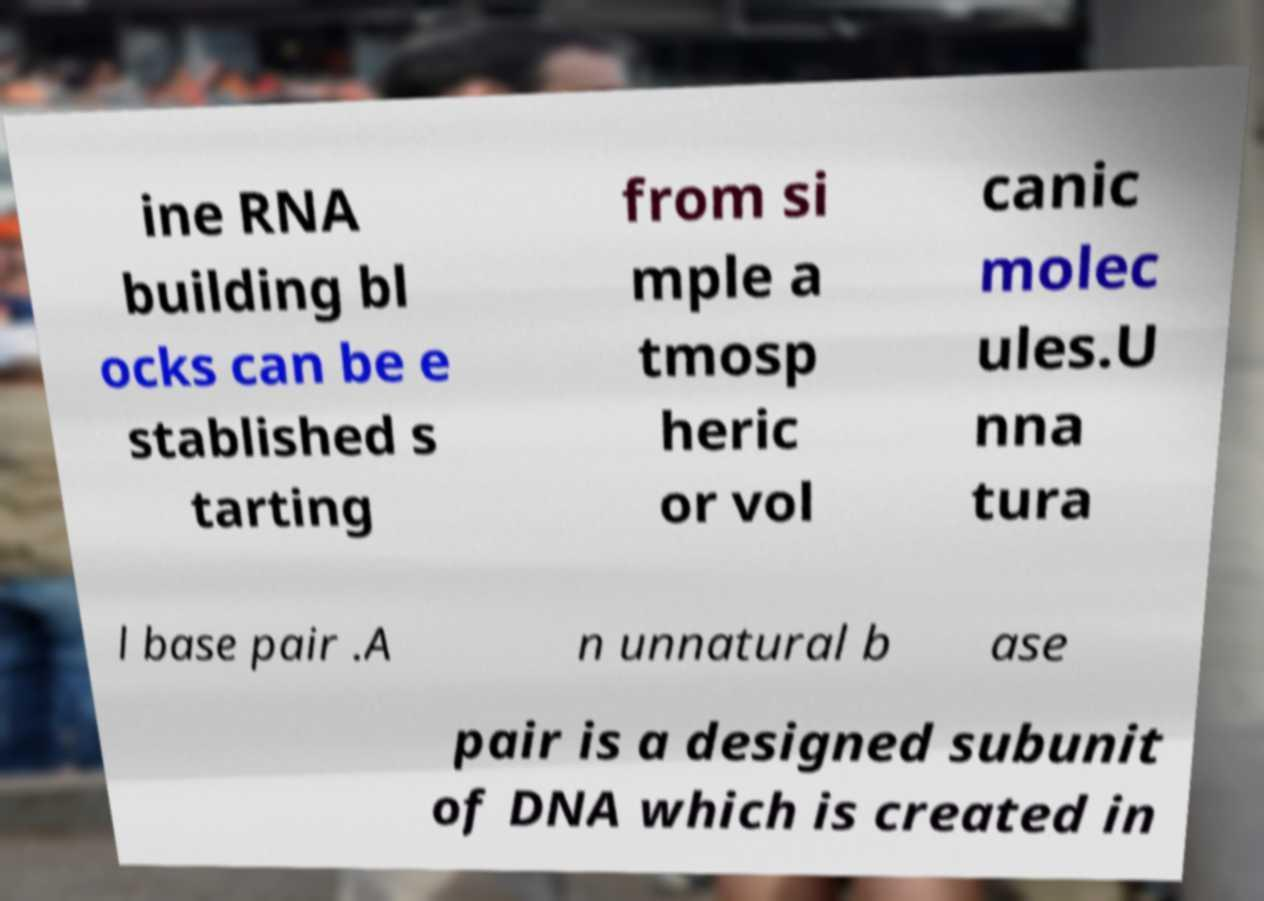Please read and relay the text visible in this image. What does it say? ine RNA building bl ocks can be e stablished s tarting from si mple a tmosp heric or vol canic molec ules.U nna tura l base pair .A n unnatural b ase pair is a designed subunit of DNA which is created in 